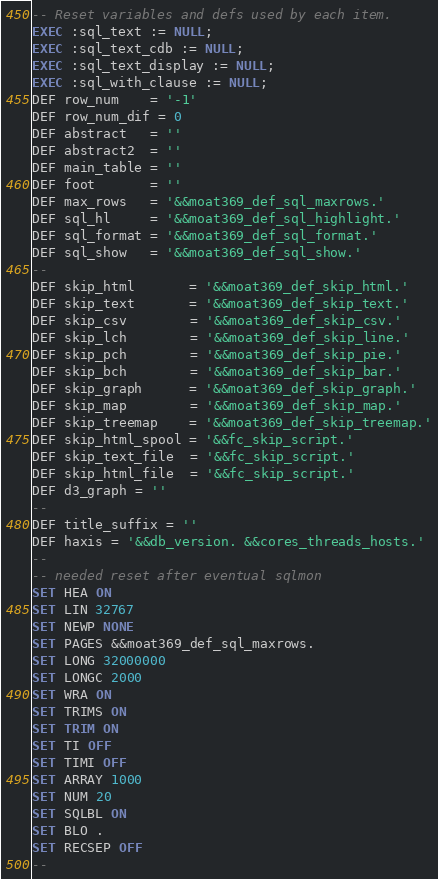Convert code to text. <code><loc_0><loc_0><loc_500><loc_500><_SQL_>-- Reset variables and defs used by each item.
EXEC :sql_text := NULL;
EXEC :sql_text_cdb := NULL;
EXEC :sql_text_display := NULL;
EXEC :sql_with_clause := NULL;
DEF row_num    = '-1'
DEF row_num_dif = 0
DEF abstract   = ''
DEF abstract2  = ''
DEF main_table = ''
DEF foot       = ''
DEF max_rows   = '&&moat369_def_sql_maxrows.'
DEF sql_hl     = '&&moat369_def_sql_highlight.'
DEF sql_format = '&&moat369_def_sql_format.'
DEF sql_show   = '&&moat369_def_sql_show.'
--
DEF skip_html       = '&&moat369_def_skip_html.'
DEF skip_text       = '&&moat369_def_skip_text.'
DEF skip_csv        = '&&moat369_def_skip_csv.'
DEF skip_lch        = '&&moat369_def_skip_line.'
DEF skip_pch        = '&&moat369_def_skip_pie.'
DEF skip_bch        = '&&moat369_def_skip_bar.'
DEF skip_graph      = '&&moat369_def_skip_graph.'
DEF skip_map        = '&&moat369_def_skip_map.'
DEF skip_treemap    = '&&moat369_def_skip_treemap.'
DEF skip_html_spool = '&&fc_skip_script.'
DEF skip_text_file  = '&&fc_skip_script.'
DEF skip_html_file  = '&&fc_skip_script.'
DEF d3_graph = ''
--
DEF title_suffix = ''
DEF haxis = '&&db_version. &&cores_threads_hosts.'
--
-- needed reset after eventual sqlmon
SET HEA ON
SET LIN 32767
SET NEWP NONE
SET PAGES &&moat369_def_sql_maxrows.
SET LONG 32000000
SET LONGC 2000
SET WRA ON
SET TRIMS ON
SET TRIM ON
SET TI OFF
SET TIMI OFF
SET ARRAY 1000
SET NUM 20
SET SQLBL ON
SET BLO .
SET RECSEP OFF
--</code> 